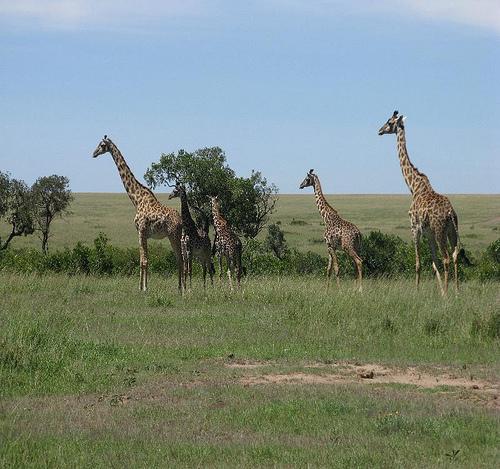What are the smaller animals to the left?
Keep it brief. Giraffe. How many elephants are pictured?
Concise answer only. 0. How many giraffes are shown?
Keep it brief. 5. Is this a herd of giraffes?
Be succinct. Yes. Are the giraffes standing still?
Answer briefly. Yes. What country was this picture likely taken in?
Keep it brief. Africa. 